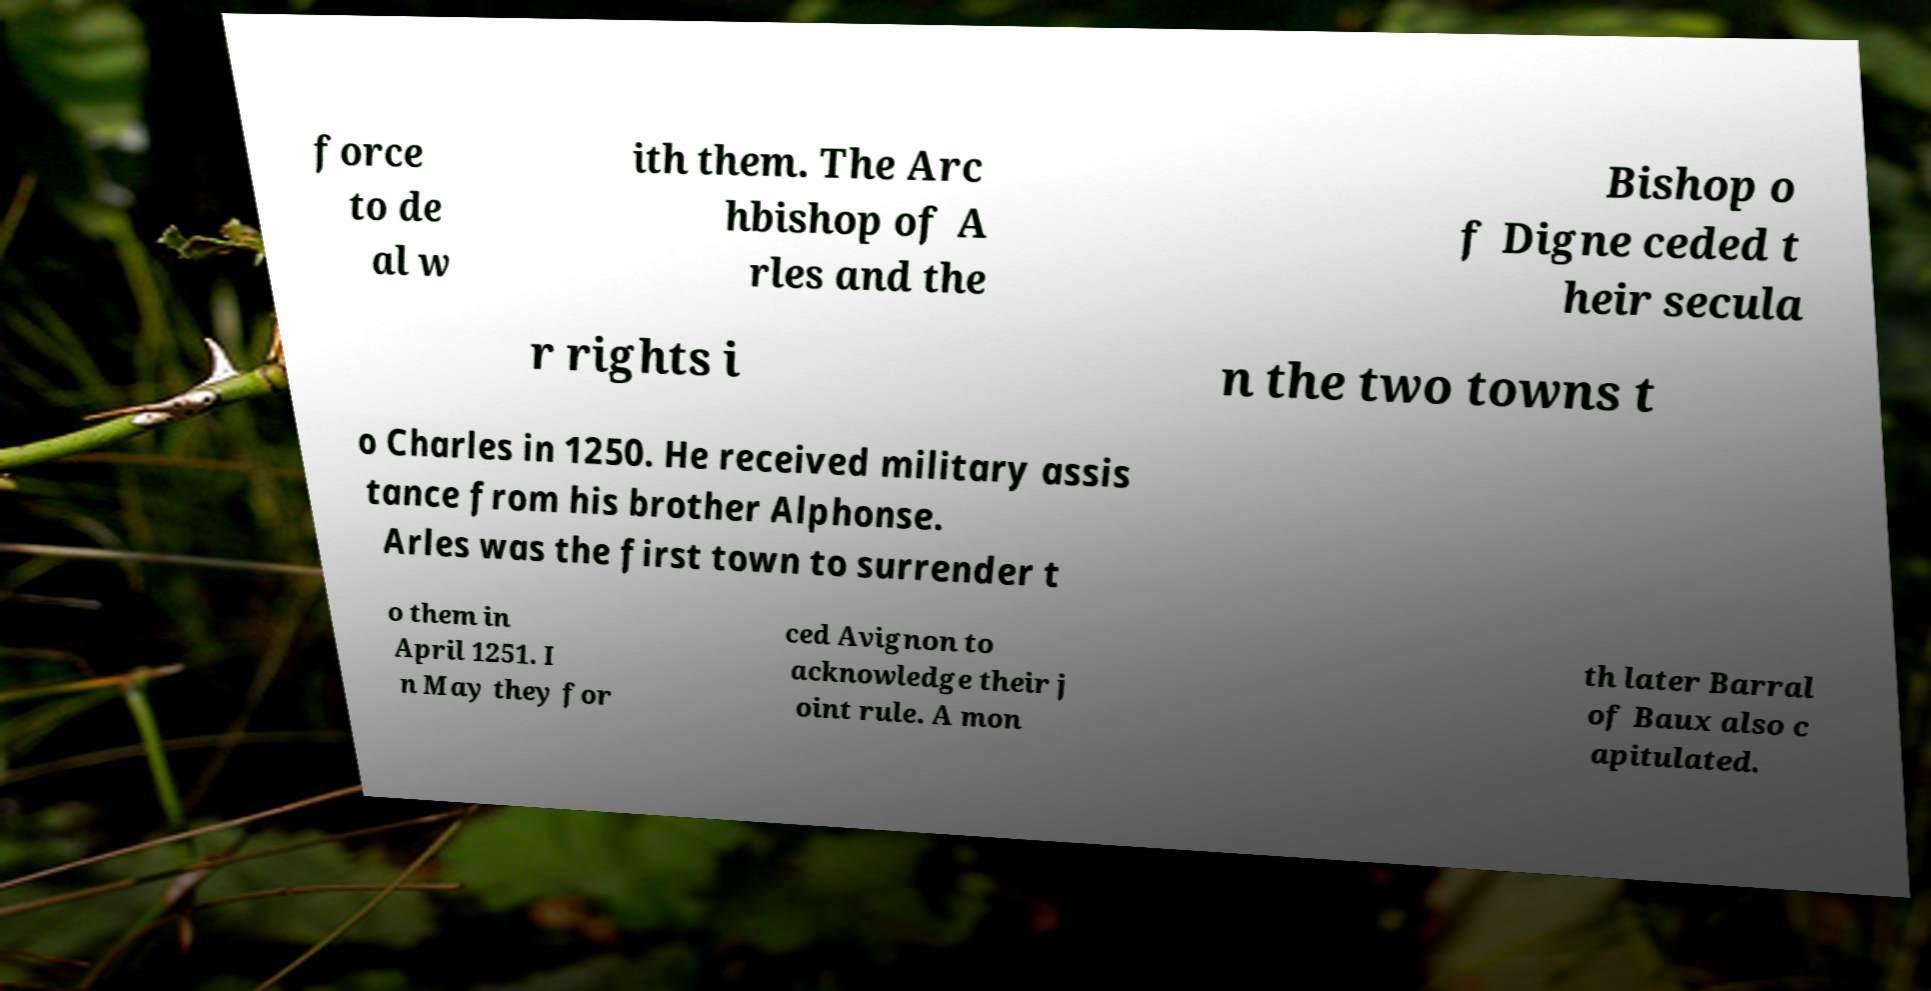There's text embedded in this image that I need extracted. Can you transcribe it verbatim? force to de al w ith them. The Arc hbishop of A rles and the Bishop o f Digne ceded t heir secula r rights i n the two towns t o Charles in 1250. He received military assis tance from his brother Alphonse. Arles was the first town to surrender t o them in April 1251. I n May they for ced Avignon to acknowledge their j oint rule. A mon th later Barral of Baux also c apitulated. 